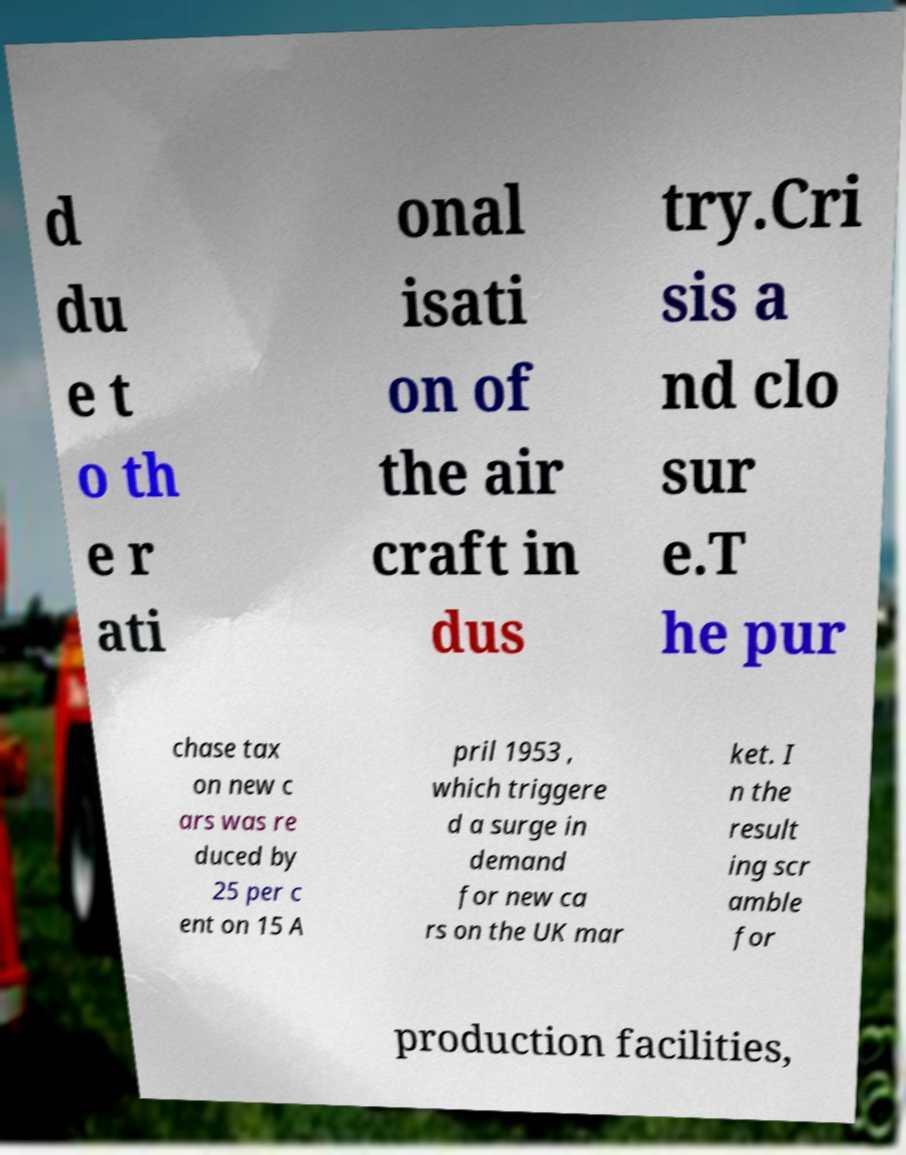I need the written content from this picture converted into text. Can you do that? d du e t o th e r ati onal isati on of the air craft in dus try.Cri sis a nd clo sur e.T he pur chase tax on new c ars was re duced by 25 per c ent on 15 A pril 1953 , which triggere d a surge in demand for new ca rs on the UK mar ket. I n the result ing scr amble for production facilities, 